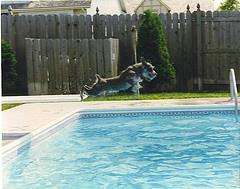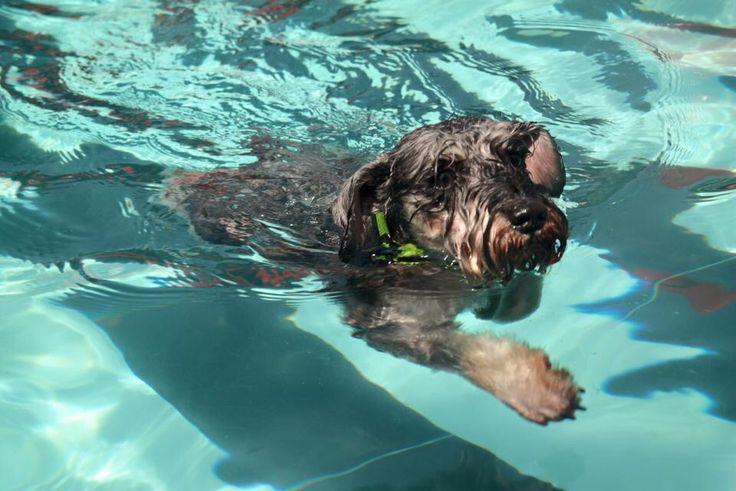The first image is the image on the left, the second image is the image on the right. For the images displayed, is the sentence "An image shows a dog in a swim ring in a pool." factually correct? Answer yes or no. No. The first image is the image on the left, the second image is the image on the right. Evaluate the accuracy of this statement regarding the images: "At least one of the dogs is on a floatation device.". Is it true? Answer yes or no. No. 